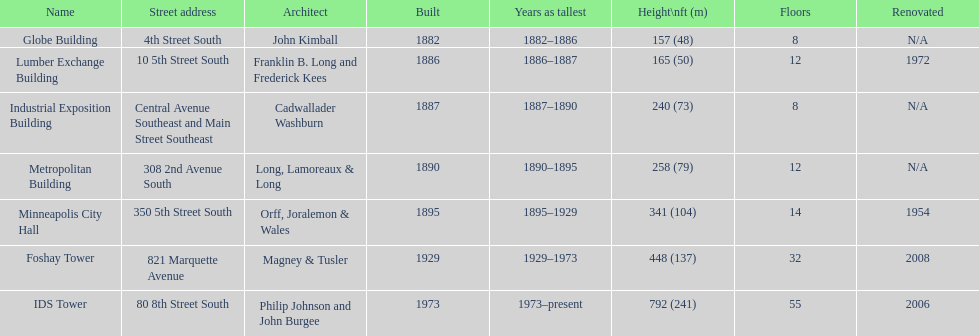How much time did the lumber exchange building remain as the tallest construction? 1 year. 